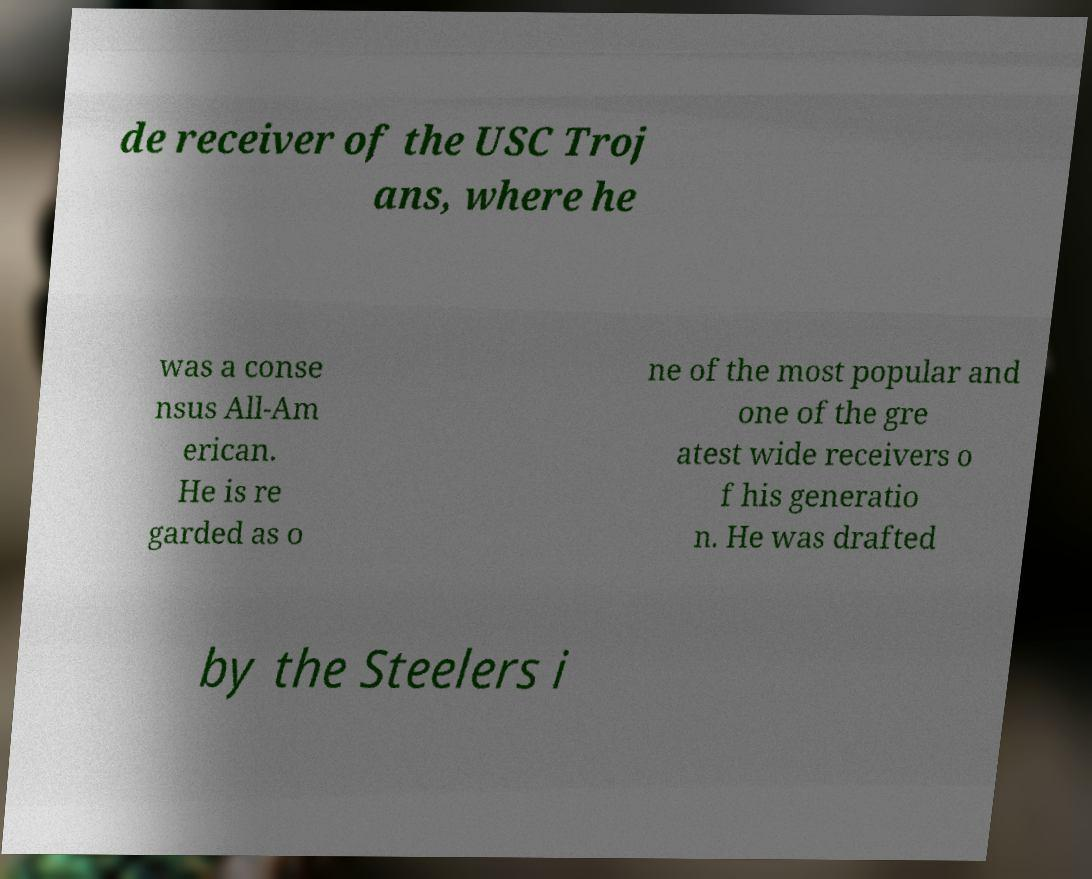For documentation purposes, I need the text within this image transcribed. Could you provide that? de receiver of the USC Troj ans, where he was a conse nsus All-Am erican. He is re garded as o ne of the most popular and one of the gre atest wide receivers o f his generatio n. He was drafted by the Steelers i 